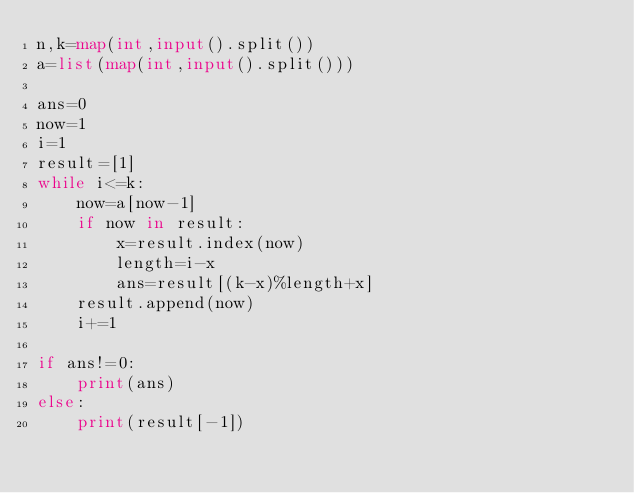Convert code to text. <code><loc_0><loc_0><loc_500><loc_500><_Python_>n,k=map(int,input().split())
a=list(map(int,input().split()))

ans=0
now=1
i=1
result=[1]
while i<=k:
    now=a[now-1]
    if now in result:
        x=result.index(now)
        length=i-x
        ans=result[(k-x)%length+x]
    result.append(now)
    i+=1
    
if ans!=0:
    print(ans)
else:
    print(result[-1])</code> 